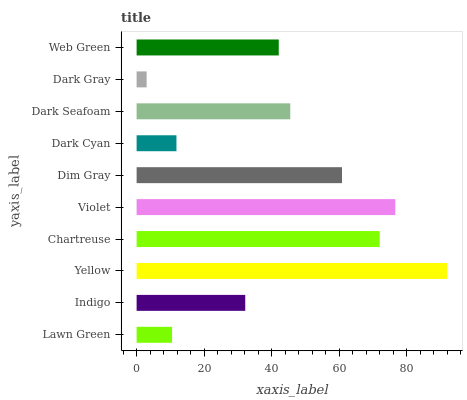Is Dark Gray the minimum?
Answer yes or no. Yes. Is Yellow the maximum?
Answer yes or no. Yes. Is Indigo the minimum?
Answer yes or no. No. Is Indigo the maximum?
Answer yes or no. No. Is Indigo greater than Lawn Green?
Answer yes or no. Yes. Is Lawn Green less than Indigo?
Answer yes or no. Yes. Is Lawn Green greater than Indigo?
Answer yes or no. No. Is Indigo less than Lawn Green?
Answer yes or no. No. Is Dark Seafoam the high median?
Answer yes or no. Yes. Is Web Green the low median?
Answer yes or no. Yes. Is Violet the high median?
Answer yes or no. No. Is Dark Cyan the low median?
Answer yes or no. No. 